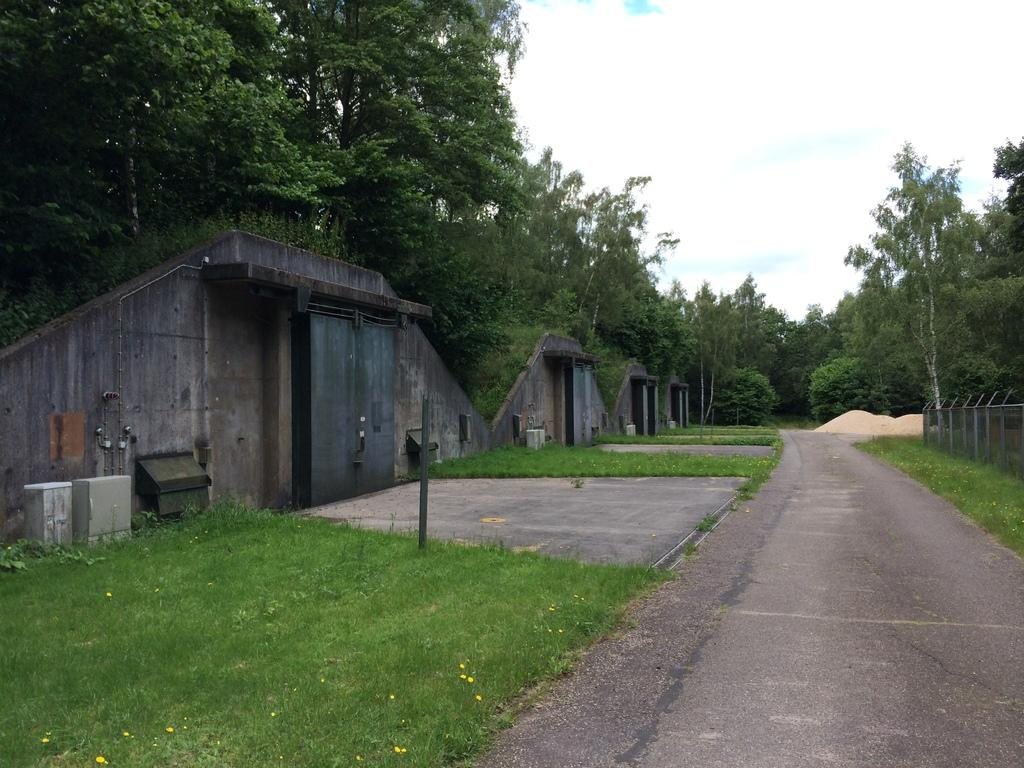What type of vegetation can be seen in the image? There are trees and grass in the image. What kind of barrier is present in the image? There is a fence in the image. What object is standing upright in the image? There is a pole in the image. What type of storage containers are visible in the image? There are boxes in the image. What type of surface can be seen in the image? There is sand in the image. What type of pathway is visible in the image? There is a road in the image. What part of the natural environment is visible in the image? The sky is visible in the image. What type of structures have doors in the image? There are walls with doors in the image. Can you see a watch on the pole in the image? There is no watch present on the pole in the image. Is there a plane flying over the trees in the image? There is no plane visible in the image. 